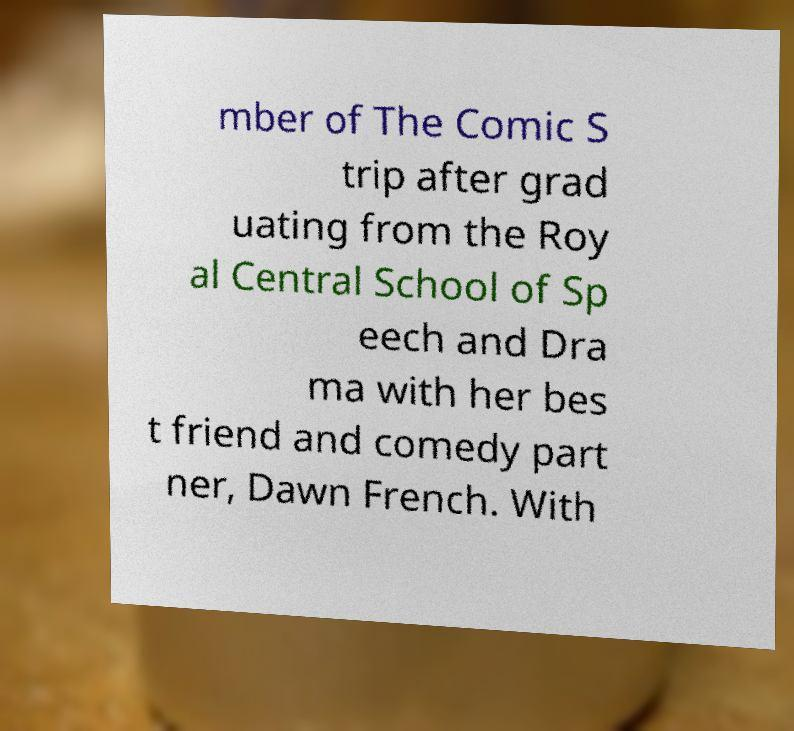Can you read and provide the text displayed in the image?This photo seems to have some interesting text. Can you extract and type it out for me? mber of The Comic S trip after grad uating from the Roy al Central School of Sp eech and Dra ma with her bes t friend and comedy part ner, Dawn French. With 